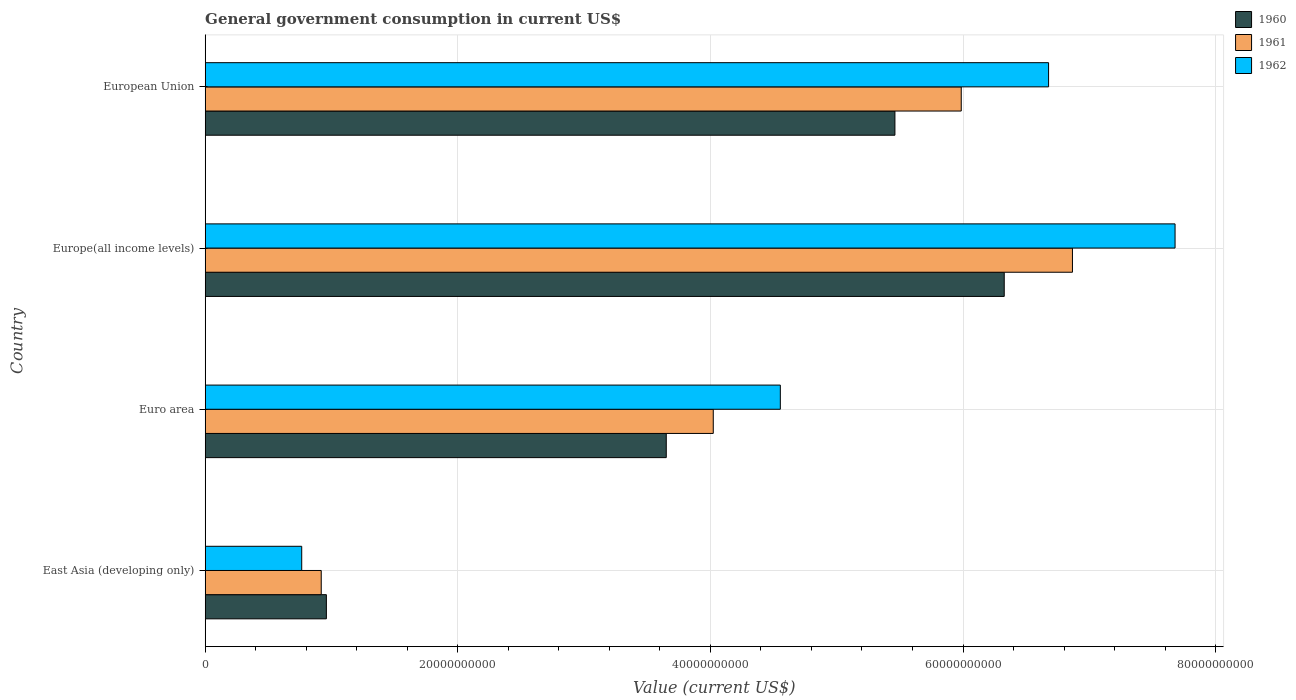How many different coloured bars are there?
Provide a short and direct response. 3. Are the number of bars per tick equal to the number of legend labels?
Your answer should be very brief. Yes. Are the number of bars on each tick of the Y-axis equal?
Ensure brevity in your answer.  Yes. How many bars are there on the 3rd tick from the bottom?
Ensure brevity in your answer.  3. What is the label of the 4th group of bars from the top?
Make the answer very short. East Asia (developing only). What is the government conusmption in 1961 in Europe(all income levels)?
Keep it short and to the point. 6.87e+1. Across all countries, what is the maximum government conusmption in 1960?
Your response must be concise. 6.33e+1. Across all countries, what is the minimum government conusmption in 1961?
Your response must be concise. 9.19e+09. In which country was the government conusmption in 1962 maximum?
Ensure brevity in your answer.  Europe(all income levels). In which country was the government conusmption in 1960 minimum?
Ensure brevity in your answer.  East Asia (developing only). What is the total government conusmption in 1962 in the graph?
Keep it short and to the point. 1.97e+11. What is the difference between the government conusmption in 1962 in East Asia (developing only) and that in Europe(all income levels)?
Offer a terse response. -6.91e+1. What is the difference between the government conusmption in 1960 in European Union and the government conusmption in 1962 in East Asia (developing only)?
Your answer should be very brief. 4.70e+1. What is the average government conusmption in 1961 per country?
Offer a terse response. 4.45e+1. What is the difference between the government conusmption in 1960 and government conusmption in 1961 in Europe(all income levels)?
Keep it short and to the point. -5.40e+09. What is the ratio of the government conusmption in 1960 in East Asia (developing only) to that in Euro area?
Provide a short and direct response. 0.26. What is the difference between the highest and the second highest government conusmption in 1961?
Your answer should be compact. 8.80e+09. What is the difference between the highest and the lowest government conusmption in 1961?
Offer a terse response. 5.95e+1. Is the sum of the government conusmption in 1962 in East Asia (developing only) and European Union greater than the maximum government conusmption in 1960 across all countries?
Your response must be concise. Yes. What does the 2nd bar from the bottom in European Union represents?
Offer a very short reply. 1961. Is it the case that in every country, the sum of the government conusmption in 1962 and government conusmption in 1961 is greater than the government conusmption in 1960?
Your answer should be very brief. Yes. How many bars are there?
Your response must be concise. 12. Are all the bars in the graph horizontal?
Your answer should be compact. Yes. What is the difference between two consecutive major ticks on the X-axis?
Offer a terse response. 2.00e+1. How many legend labels are there?
Offer a terse response. 3. How are the legend labels stacked?
Keep it short and to the point. Vertical. What is the title of the graph?
Your answer should be compact. General government consumption in current US$. Does "1996" appear as one of the legend labels in the graph?
Your answer should be very brief. No. What is the label or title of the X-axis?
Offer a terse response. Value (current US$). What is the label or title of the Y-axis?
Your answer should be compact. Country. What is the Value (current US$) of 1960 in East Asia (developing only)?
Your answer should be very brief. 9.59e+09. What is the Value (current US$) of 1961 in East Asia (developing only)?
Offer a very short reply. 9.19e+09. What is the Value (current US$) in 1962 in East Asia (developing only)?
Ensure brevity in your answer.  7.64e+09. What is the Value (current US$) of 1960 in Euro area?
Provide a succinct answer. 3.65e+1. What is the Value (current US$) of 1961 in Euro area?
Your answer should be compact. 4.02e+1. What is the Value (current US$) of 1962 in Euro area?
Your answer should be very brief. 4.55e+1. What is the Value (current US$) of 1960 in Europe(all income levels)?
Ensure brevity in your answer.  6.33e+1. What is the Value (current US$) of 1961 in Europe(all income levels)?
Make the answer very short. 6.87e+1. What is the Value (current US$) in 1962 in Europe(all income levels)?
Provide a short and direct response. 7.68e+1. What is the Value (current US$) in 1960 in European Union?
Keep it short and to the point. 5.46e+1. What is the Value (current US$) of 1961 in European Union?
Make the answer very short. 5.99e+1. What is the Value (current US$) in 1962 in European Union?
Your answer should be compact. 6.68e+1. Across all countries, what is the maximum Value (current US$) of 1960?
Make the answer very short. 6.33e+1. Across all countries, what is the maximum Value (current US$) in 1961?
Make the answer very short. 6.87e+1. Across all countries, what is the maximum Value (current US$) in 1962?
Your answer should be very brief. 7.68e+1. Across all countries, what is the minimum Value (current US$) of 1960?
Your answer should be compact. 9.59e+09. Across all countries, what is the minimum Value (current US$) of 1961?
Ensure brevity in your answer.  9.19e+09. Across all countries, what is the minimum Value (current US$) of 1962?
Provide a short and direct response. 7.64e+09. What is the total Value (current US$) in 1960 in the graph?
Give a very brief answer. 1.64e+11. What is the total Value (current US$) in 1961 in the graph?
Give a very brief answer. 1.78e+11. What is the total Value (current US$) in 1962 in the graph?
Make the answer very short. 1.97e+11. What is the difference between the Value (current US$) of 1960 in East Asia (developing only) and that in Euro area?
Your answer should be compact. -2.69e+1. What is the difference between the Value (current US$) of 1961 in East Asia (developing only) and that in Euro area?
Provide a succinct answer. -3.10e+1. What is the difference between the Value (current US$) of 1962 in East Asia (developing only) and that in Euro area?
Your response must be concise. -3.79e+1. What is the difference between the Value (current US$) of 1960 in East Asia (developing only) and that in Europe(all income levels)?
Provide a short and direct response. -5.37e+1. What is the difference between the Value (current US$) of 1961 in East Asia (developing only) and that in Europe(all income levels)?
Your answer should be very brief. -5.95e+1. What is the difference between the Value (current US$) of 1962 in East Asia (developing only) and that in Europe(all income levels)?
Offer a very short reply. -6.91e+1. What is the difference between the Value (current US$) in 1960 in East Asia (developing only) and that in European Union?
Make the answer very short. -4.50e+1. What is the difference between the Value (current US$) of 1961 in East Asia (developing only) and that in European Union?
Offer a terse response. -5.07e+1. What is the difference between the Value (current US$) in 1962 in East Asia (developing only) and that in European Union?
Offer a terse response. -5.91e+1. What is the difference between the Value (current US$) of 1960 in Euro area and that in Europe(all income levels)?
Ensure brevity in your answer.  -2.68e+1. What is the difference between the Value (current US$) of 1961 in Euro area and that in Europe(all income levels)?
Provide a succinct answer. -2.84e+1. What is the difference between the Value (current US$) of 1962 in Euro area and that in Europe(all income levels)?
Keep it short and to the point. -3.13e+1. What is the difference between the Value (current US$) in 1960 in Euro area and that in European Union?
Your answer should be very brief. -1.81e+1. What is the difference between the Value (current US$) of 1961 in Euro area and that in European Union?
Your answer should be very brief. -1.96e+1. What is the difference between the Value (current US$) of 1962 in Euro area and that in European Union?
Ensure brevity in your answer.  -2.12e+1. What is the difference between the Value (current US$) of 1960 in Europe(all income levels) and that in European Union?
Provide a succinct answer. 8.66e+09. What is the difference between the Value (current US$) of 1961 in Europe(all income levels) and that in European Union?
Make the answer very short. 8.80e+09. What is the difference between the Value (current US$) in 1962 in Europe(all income levels) and that in European Union?
Your answer should be compact. 1.00e+1. What is the difference between the Value (current US$) of 1960 in East Asia (developing only) and the Value (current US$) of 1961 in Euro area?
Your answer should be very brief. -3.06e+1. What is the difference between the Value (current US$) in 1960 in East Asia (developing only) and the Value (current US$) in 1962 in Euro area?
Your response must be concise. -3.59e+1. What is the difference between the Value (current US$) in 1961 in East Asia (developing only) and the Value (current US$) in 1962 in Euro area?
Your response must be concise. -3.63e+1. What is the difference between the Value (current US$) in 1960 in East Asia (developing only) and the Value (current US$) in 1961 in Europe(all income levels)?
Your answer should be compact. -5.91e+1. What is the difference between the Value (current US$) in 1960 in East Asia (developing only) and the Value (current US$) in 1962 in Europe(all income levels)?
Keep it short and to the point. -6.72e+1. What is the difference between the Value (current US$) in 1961 in East Asia (developing only) and the Value (current US$) in 1962 in Europe(all income levels)?
Offer a very short reply. -6.76e+1. What is the difference between the Value (current US$) in 1960 in East Asia (developing only) and the Value (current US$) in 1961 in European Union?
Your answer should be compact. -5.03e+1. What is the difference between the Value (current US$) in 1960 in East Asia (developing only) and the Value (current US$) in 1962 in European Union?
Provide a succinct answer. -5.72e+1. What is the difference between the Value (current US$) of 1961 in East Asia (developing only) and the Value (current US$) of 1962 in European Union?
Your answer should be compact. -5.76e+1. What is the difference between the Value (current US$) of 1960 in Euro area and the Value (current US$) of 1961 in Europe(all income levels)?
Your answer should be very brief. -3.22e+1. What is the difference between the Value (current US$) in 1960 in Euro area and the Value (current US$) in 1962 in Europe(all income levels)?
Your answer should be compact. -4.03e+1. What is the difference between the Value (current US$) in 1961 in Euro area and the Value (current US$) in 1962 in Europe(all income levels)?
Your answer should be compact. -3.66e+1. What is the difference between the Value (current US$) in 1960 in Euro area and the Value (current US$) in 1961 in European Union?
Offer a very short reply. -2.34e+1. What is the difference between the Value (current US$) in 1960 in Euro area and the Value (current US$) in 1962 in European Union?
Offer a terse response. -3.03e+1. What is the difference between the Value (current US$) of 1961 in Euro area and the Value (current US$) of 1962 in European Union?
Provide a succinct answer. -2.65e+1. What is the difference between the Value (current US$) of 1960 in Europe(all income levels) and the Value (current US$) of 1961 in European Union?
Your answer should be very brief. 3.40e+09. What is the difference between the Value (current US$) in 1960 in Europe(all income levels) and the Value (current US$) in 1962 in European Union?
Offer a very short reply. -3.51e+09. What is the difference between the Value (current US$) in 1961 in Europe(all income levels) and the Value (current US$) in 1962 in European Union?
Give a very brief answer. 1.89e+09. What is the average Value (current US$) of 1960 per country?
Keep it short and to the point. 4.10e+1. What is the average Value (current US$) of 1961 per country?
Offer a terse response. 4.45e+1. What is the average Value (current US$) of 1962 per country?
Your response must be concise. 4.92e+1. What is the difference between the Value (current US$) in 1960 and Value (current US$) in 1961 in East Asia (developing only)?
Offer a very short reply. 4.07e+08. What is the difference between the Value (current US$) in 1960 and Value (current US$) in 1962 in East Asia (developing only)?
Give a very brief answer. 1.95e+09. What is the difference between the Value (current US$) of 1961 and Value (current US$) of 1962 in East Asia (developing only)?
Ensure brevity in your answer.  1.55e+09. What is the difference between the Value (current US$) in 1960 and Value (current US$) in 1961 in Euro area?
Offer a very short reply. -3.72e+09. What is the difference between the Value (current US$) in 1960 and Value (current US$) in 1962 in Euro area?
Offer a terse response. -9.03e+09. What is the difference between the Value (current US$) in 1961 and Value (current US$) in 1962 in Euro area?
Provide a short and direct response. -5.31e+09. What is the difference between the Value (current US$) in 1960 and Value (current US$) in 1961 in Europe(all income levels)?
Provide a succinct answer. -5.40e+09. What is the difference between the Value (current US$) of 1960 and Value (current US$) of 1962 in Europe(all income levels)?
Offer a very short reply. -1.35e+1. What is the difference between the Value (current US$) in 1961 and Value (current US$) in 1962 in Europe(all income levels)?
Keep it short and to the point. -8.12e+09. What is the difference between the Value (current US$) of 1960 and Value (current US$) of 1961 in European Union?
Your answer should be compact. -5.25e+09. What is the difference between the Value (current US$) of 1960 and Value (current US$) of 1962 in European Union?
Your answer should be very brief. -1.22e+1. What is the difference between the Value (current US$) in 1961 and Value (current US$) in 1962 in European Union?
Your response must be concise. -6.91e+09. What is the ratio of the Value (current US$) in 1960 in East Asia (developing only) to that in Euro area?
Offer a very short reply. 0.26. What is the ratio of the Value (current US$) of 1961 in East Asia (developing only) to that in Euro area?
Offer a terse response. 0.23. What is the ratio of the Value (current US$) in 1962 in East Asia (developing only) to that in Euro area?
Your answer should be very brief. 0.17. What is the ratio of the Value (current US$) of 1960 in East Asia (developing only) to that in Europe(all income levels)?
Provide a succinct answer. 0.15. What is the ratio of the Value (current US$) of 1961 in East Asia (developing only) to that in Europe(all income levels)?
Ensure brevity in your answer.  0.13. What is the ratio of the Value (current US$) in 1962 in East Asia (developing only) to that in Europe(all income levels)?
Give a very brief answer. 0.1. What is the ratio of the Value (current US$) in 1960 in East Asia (developing only) to that in European Union?
Keep it short and to the point. 0.18. What is the ratio of the Value (current US$) of 1961 in East Asia (developing only) to that in European Union?
Offer a very short reply. 0.15. What is the ratio of the Value (current US$) in 1962 in East Asia (developing only) to that in European Union?
Give a very brief answer. 0.11. What is the ratio of the Value (current US$) in 1960 in Euro area to that in Europe(all income levels)?
Your answer should be compact. 0.58. What is the ratio of the Value (current US$) in 1961 in Euro area to that in Europe(all income levels)?
Your response must be concise. 0.59. What is the ratio of the Value (current US$) of 1962 in Euro area to that in Europe(all income levels)?
Provide a succinct answer. 0.59. What is the ratio of the Value (current US$) in 1960 in Euro area to that in European Union?
Provide a short and direct response. 0.67. What is the ratio of the Value (current US$) in 1961 in Euro area to that in European Union?
Provide a succinct answer. 0.67. What is the ratio of the Value (current US$) of 1962 in Euro area to that in European Union?
Offer a very short reply. 0.68. What is the ratio of the Value (current US$) in 1960 in Europe(all income levels) to that in European Union?
Ensure brevity in your answer.  1.16. What is the ratio of the Value (current US$) in 1961 in Europe(all income levels) to that in European Union?
Your response must be concise. 1.15. What is the ratio of the Value (current US$) in 1962 in Europe(all income levels) to that in European Union?
Offer a very short reply. 1.15. What is the difference between the highest and the second highest Value (current US$) in 1960?
Give a very brief answer. 8.66e+09. What is the difference between the highest and the second highest Value (current US$) of 1961?
Your answer should be compact. 8.80e+09. What is the difference between the highest and the second highest Value (current US$) of 1962?
Your answer should be compact. 1.00e+1. What is the difference between the highest and the lowest Value (current US$) of 1960?
Offer a very short reply. 5.37e+1. What is the difference between the highest and the lowest Value (current US$) of 1961?
Your response must be concise. 5.95e+1. What is the difference between the highest and the lowest Value (current US$) of 1962?
Your answer should be compact. 6.91e+1. 